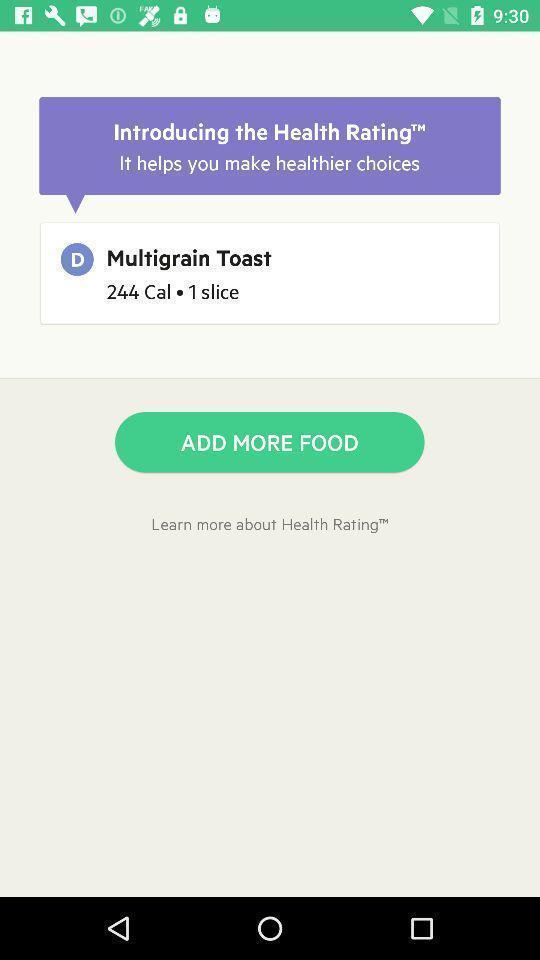Explain what's happening in this screen capture. Screen shows multiple options in a diet application. 